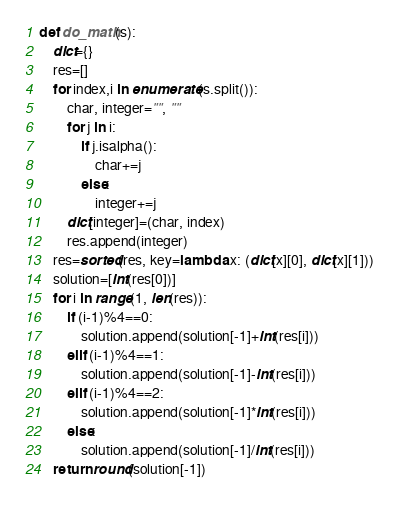Convert code to text. <code><loc_0><loc_0><loc_500><loc_500><_Python_>def do_math(s):
    dict={}
    res=[]
    for index,i in enumerate(s.split()):
        char, integer="", ""
        for j in i:
            if j.isalpha():
                char+=j
            else:
                integer+=j
        dict[integer]=(char, index)
        res.append(integer)
    res=sorted(res, key=lambda x: (dict[x][0], dict[x][1]))
    solution=[int(res[0])] 
    for i in range(1, len(res)):
        if (i-1)%4==0:
            solution.append(solution[-1]+int(res[i]))
        elif (i-1)%4==1:
            solution.append(solution[-1]-int(res[i]))
        elif (i-1)%4==2:
            solution.append(solution[-1]*int(res[i]))
        else:
            solution.append(solution[-1]/int(res[i]))
    return round(solution[-1])</code> 